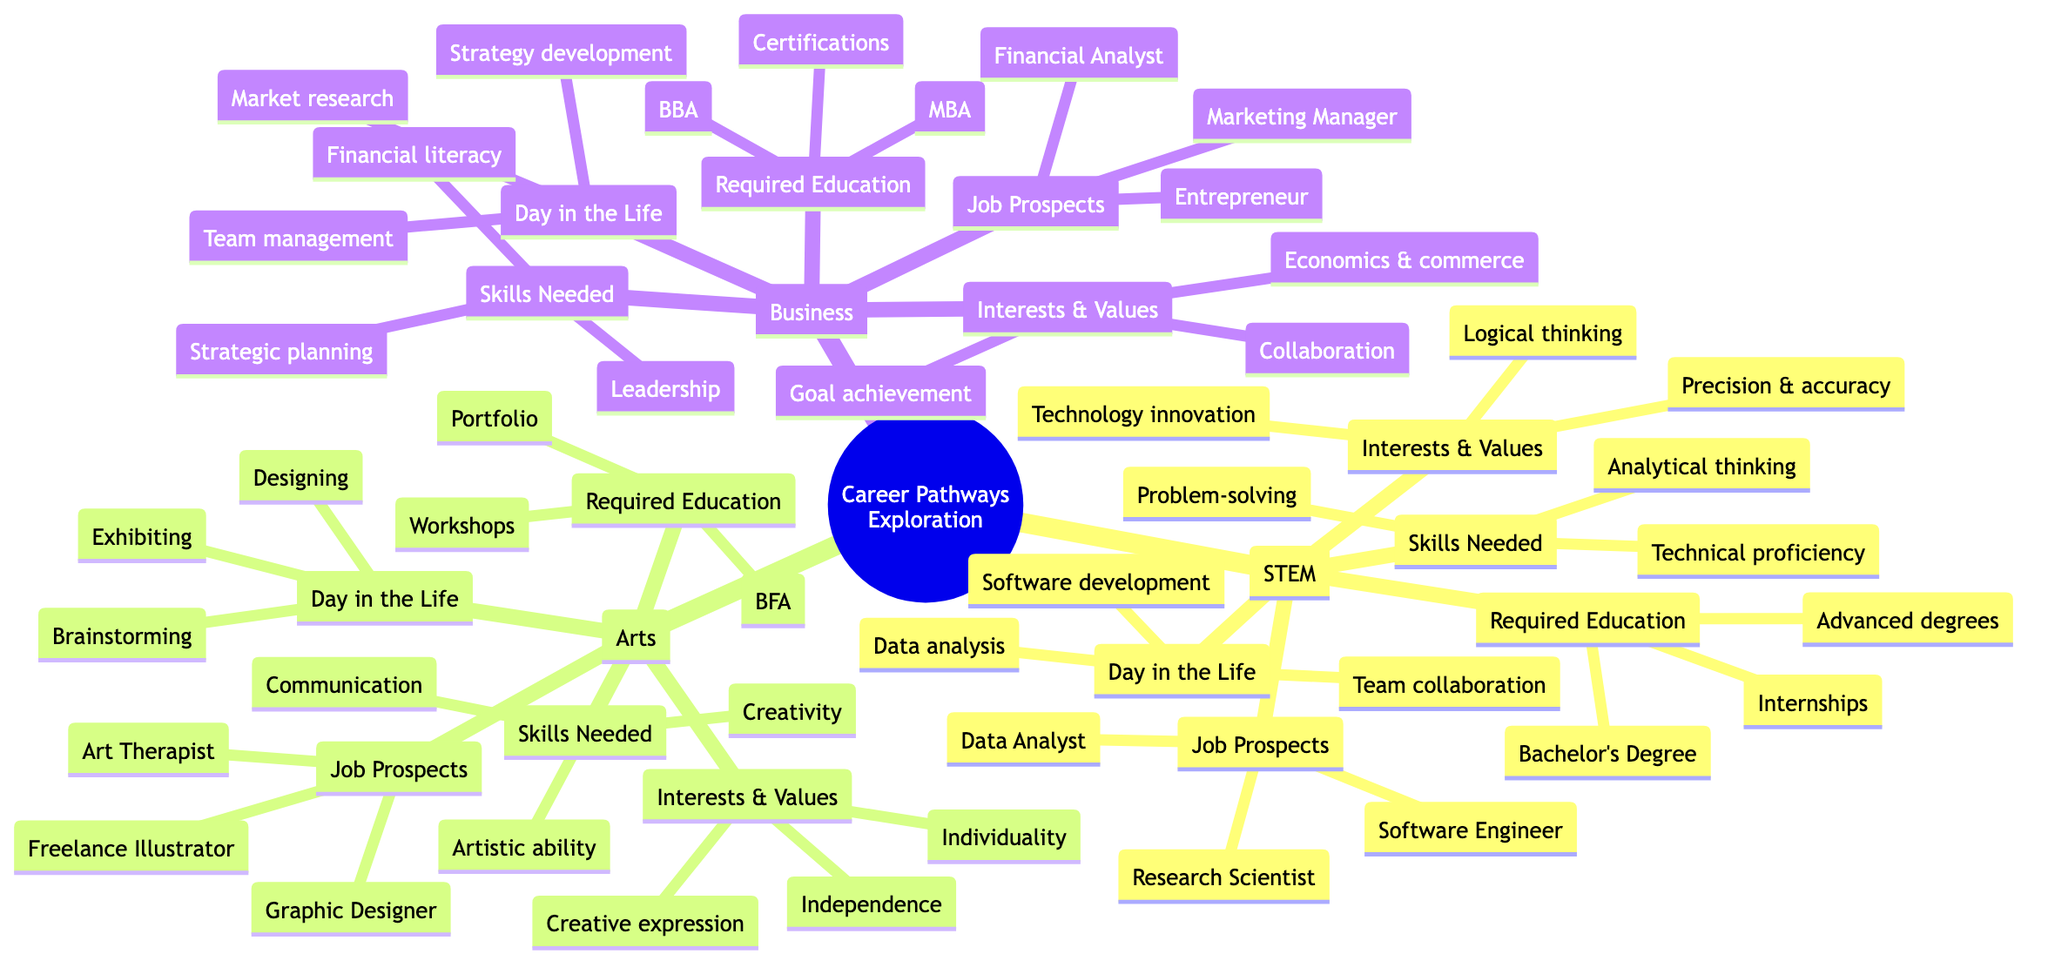What is a job prospect in STEM? The diagram lists job prospects under the STEM category, specifically naming roles such as Software Engineer, Research Scientist, and Data Analyst. Any of these roles would be correct.
Answer: Software Engineer How many skills are listed for the Arts pathway? The Arts category outlines three specific skills needed: Creativity, Artistic ability, and Communication skills. Therefore, by counting them, it can be determined that there are three skills.
Answer: 3 What is one required education item for a Business career? The diagram presents the required education for the Business pathway, specifying several options. One of the listed items is a Bachelor's Degree in Business Administration.
Answer: Bachelor's Degree in Business Administration Which pathway values creativity and individuality? Analyzing the Interests & Values section under each pathway, it becomes clear that the Arts pathway emphasizes both creativity and individuality.
Answer: Arts What is the focus of a typical day in the life of someone in STEM? The Day in the Life section highlights typical activities in the STEM field, such as team collaboration, software development, and data analysis. Summarizing, this focuses primarily on team collaboration.
Answer: Team collaboration What are the three job prospects listed under Business? By examining the Job Prospects section in the Business path, the diagram includes specific roles: Marketing Manager, Financial Analyst, and Entrepreneur. These three positions represent the potential career opportunities.
Answer: Marketing Manager, Financial Analyst, Entrepreneur What skill is essential for someone pursuing a career in Business? Referring to the Skills Needed section for Business, the three skills listed include Leadership, Financial literacy, and Strategic planning, indicating the importance of Leadership as a relevant skill.
Answer: Leadership How does the Arts pathway suggest one can develop relevant education? The Education component highlights several methods to enhance education in the Arts, including portfolio development, workshops, and private mentorship. Any of these would be appropriate methods of development.
Answer: Portfolio development What interest aligns with the STEM pathway? The Interests & Values section of the STEM pathway mentions a clear interest in technology and innovation, making it a direct alignment with this field.
Answer: Technology and innovation 